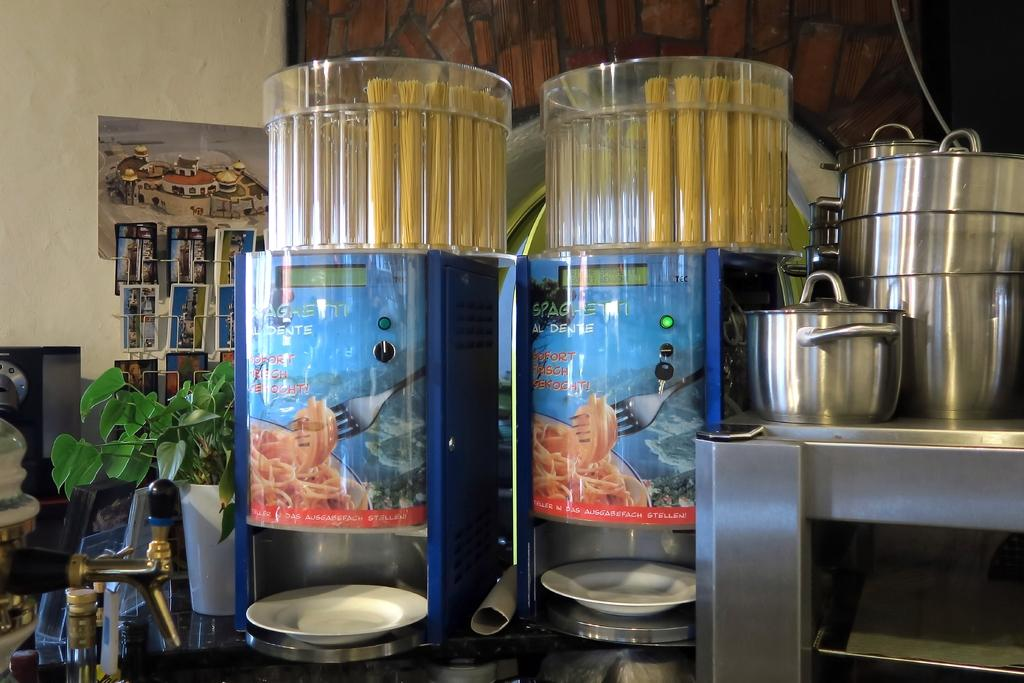<image>
Give a short and clear explanation of the subsequent image. A kitchen scene with some food containers saying Sohort Reicht. 